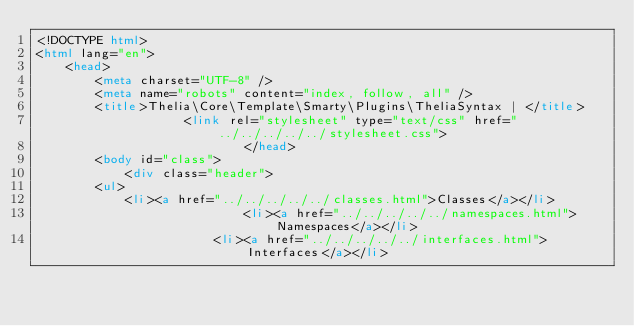Convert code to text. <code><loc_0><loc_0><loc_500><loc_500><_HTML_><!DOCTYPE html>
<html lang="en">
    <head>
        <meta charset="UTF-8" />
        <meta name="robots" content="index, follow, all" />
        <title>Thelia\Core\Template\Smarty\Plugins\TheliaSyntax | </title>
                    <link rel="stylesheet" type="text/css" href="../../../../../stylesheet.css">
                            </head>
        <body id="class">
            <div class="header">
        <ul>
            <li><a href="../../../../../classes.html">Classes</a></li>
                            <li><a href="../../../../../namespaces.html">Namespaces</a></li>
                        <li><a href="../../../../../interfaces.html">Interfaces</a></li></code> 